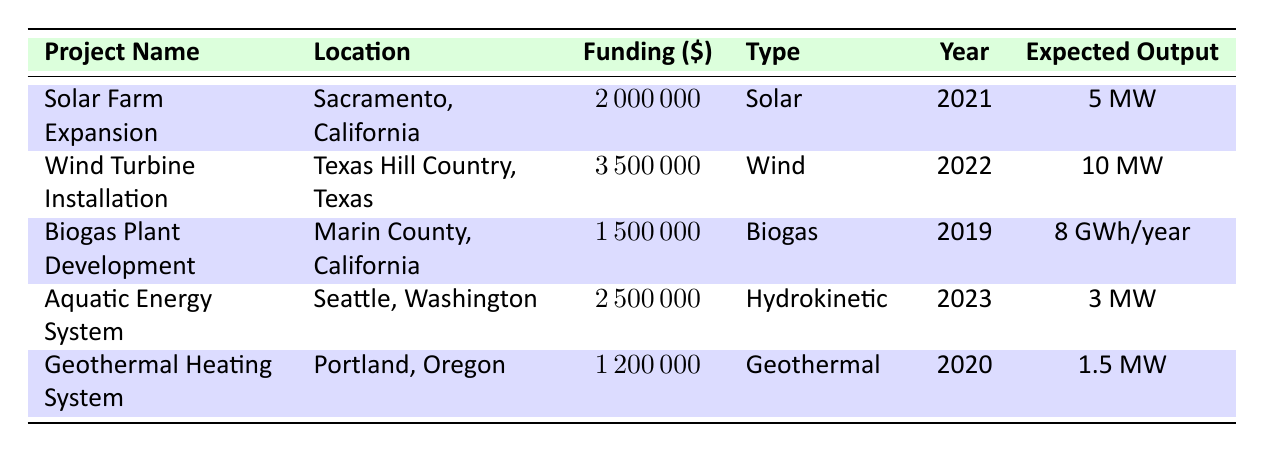What is the total funding amount for all projects listed? To find the total funding amount, we add the funding amounts for all five projects together: 2000000 + 3500000 + 1500000 + 2500000 + 1200000 = 11200000.
Answer: 11200000 Which project had the highest expected output? The project with the highest expected output is the Wind Turbine Installation in Texas, which produces 10 MW.
Answer: Wind Turbine Installation Is there any project funded in 2023? Yes, there is one project funded in 2023, which is the Aquatic Energy System in Seattle, Washington.
Answer: Yes What is the average funding amount across all projects? To find the average funding amount, sum all funding amounts (2000000 + 3500000 + 1500000 + 2500000 + 1200000 = 11200000) and divide by the number of projects (5). So, 11200000 / 5 = 2240000.
Answer: 2240000 Did the Solar Farm Expansion have a higher funding amount than the Geothermal Heating System? Yes, the Solar Farm Expansion received 2000000, which is higher than the Geothermal Heating System's funding of 1200000.
Answer: Yes How many projects are designed for Solar energy? There is one project designed for Solar energy, which is the Solar Farm Expansion.
Answer: 1 Which project type has the lowest funding amount? The Geothermal Heating System has the lowest funding amount of 1200000.
Answer: Geothermal What is the difference in expected output between the Wind Turbine Installation and the Geothermal Heating System? The Wind Turbine Installation has an expected output of 10 MW, while the Geothermal Heating System has an output of 1.5 MW. The difference is 10 - 1.5 = 8.5 MW.
Answer: 8.5 MW Which locations have projects funded in 2020 and 2022? The Geothermal Heating System in Portland, Oregon was funded in 2020, and the Wind Turbine Installation in Texas Hill Country, Texas was funded in 2022.
Answer: Portland, Oregon and Texas Hill Country, Texas 